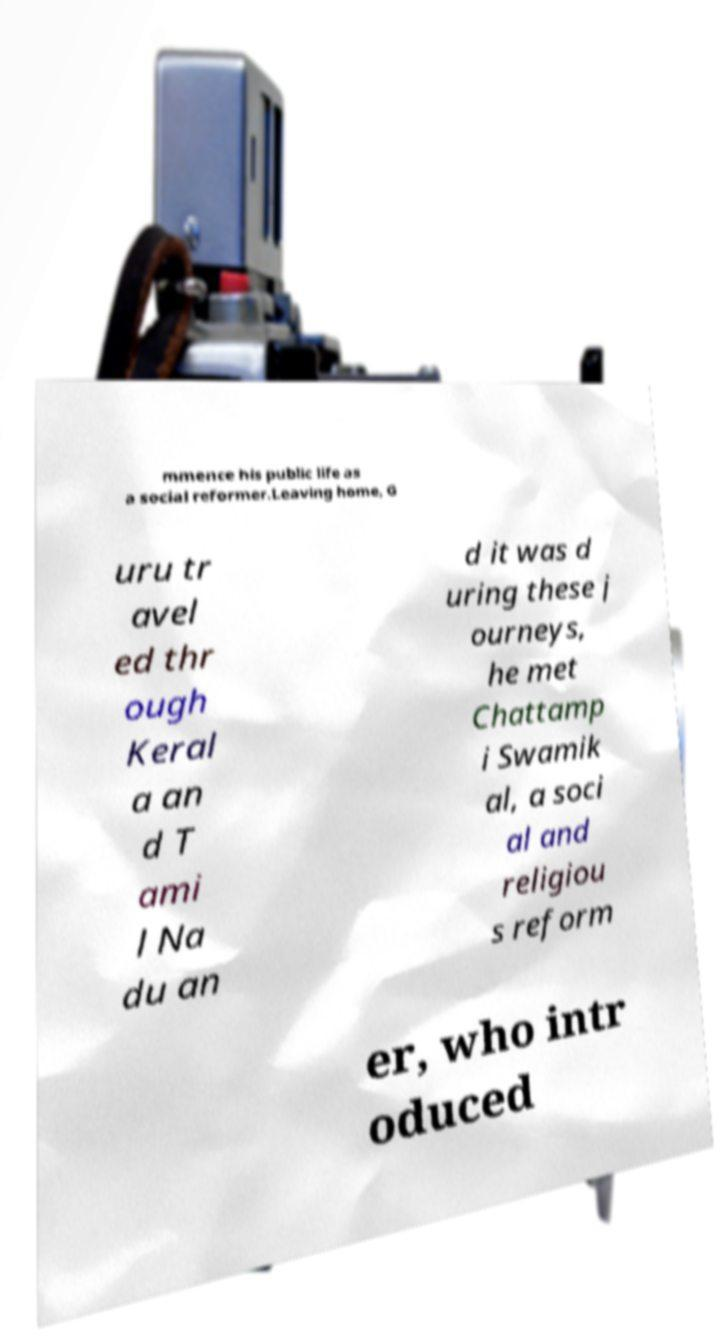What messages or text are displayed in this image? I need them in a readable, typed format. mmence his public life as a social reformer.Leaving home, G uru tr avel ed thr ough Keral a an d T ami l Na du an d it was d uring these j ourneys, he met Chattamp i Swamik al, a soci al and religiou s reform er, who intr oduced 